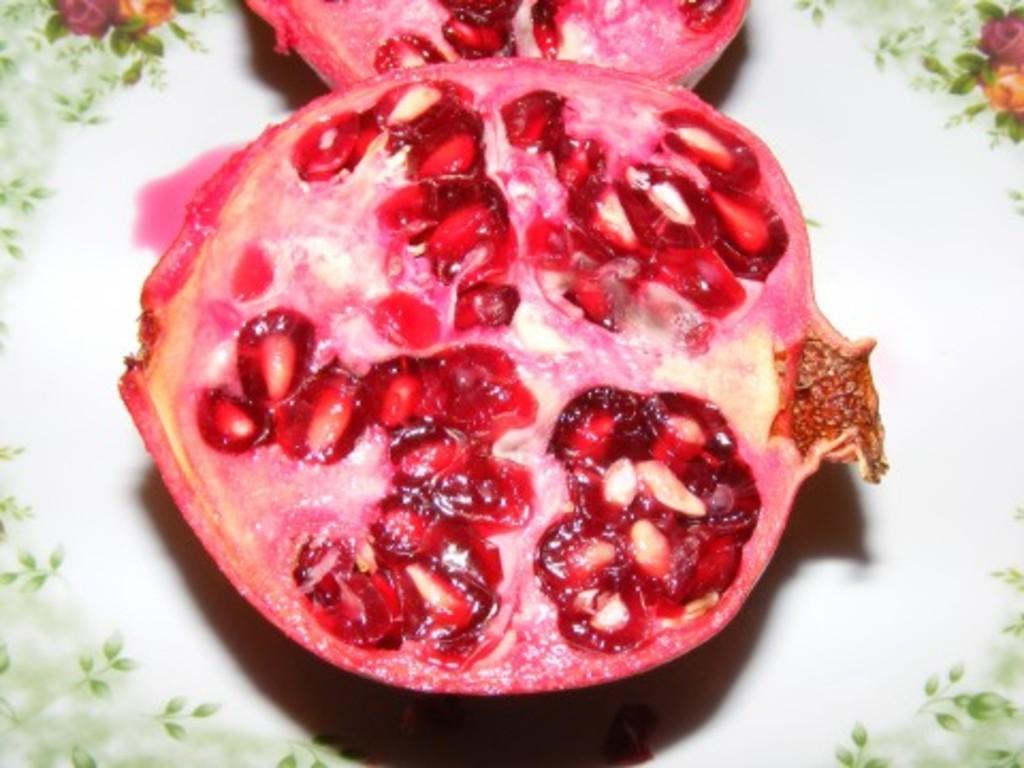What fruit is visible in the image? There is a pomegranate in the image. How is the pomegranate presented in the image? The pomegranate is placed on a plate. What is the annual income of the person who owns the pomegranate in the image? There is no information about the owner of the pomegranate or their income in the image. 